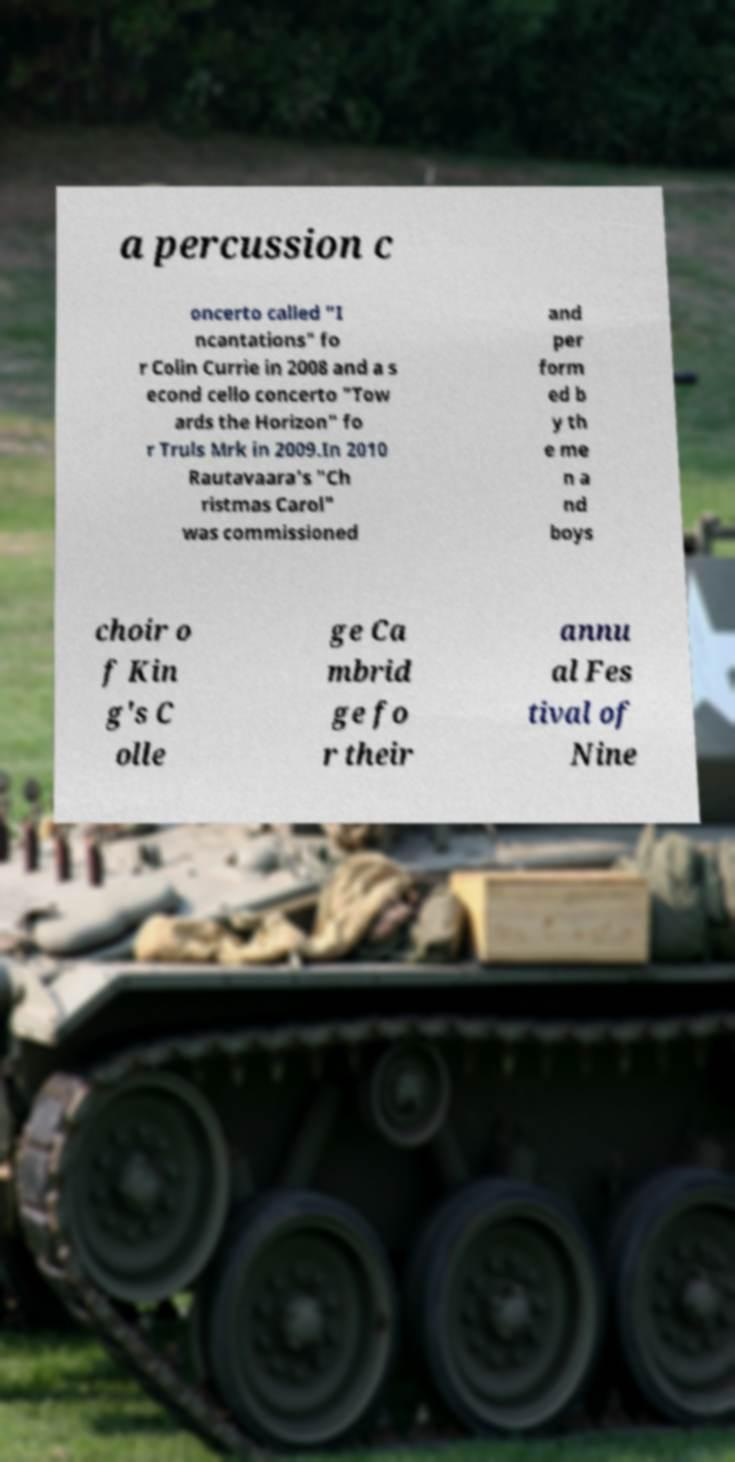What messages or text are displayed in this image? I need them in a readable, typed format. a percussion c oncerto called "I ncantations" fo r Colin Currie in 2008 and a s econd cello concerto "Tow ards the Horizon" fo r Truls Mrk in 2009.In 2010 Rautavaara's "Ch ristmas Carol" was commissioned and per form ed b y th e me n a nd boys choir o f Kin g's C olle ge Ca mbrid ge fo r their annu al Fes tival of Nine 